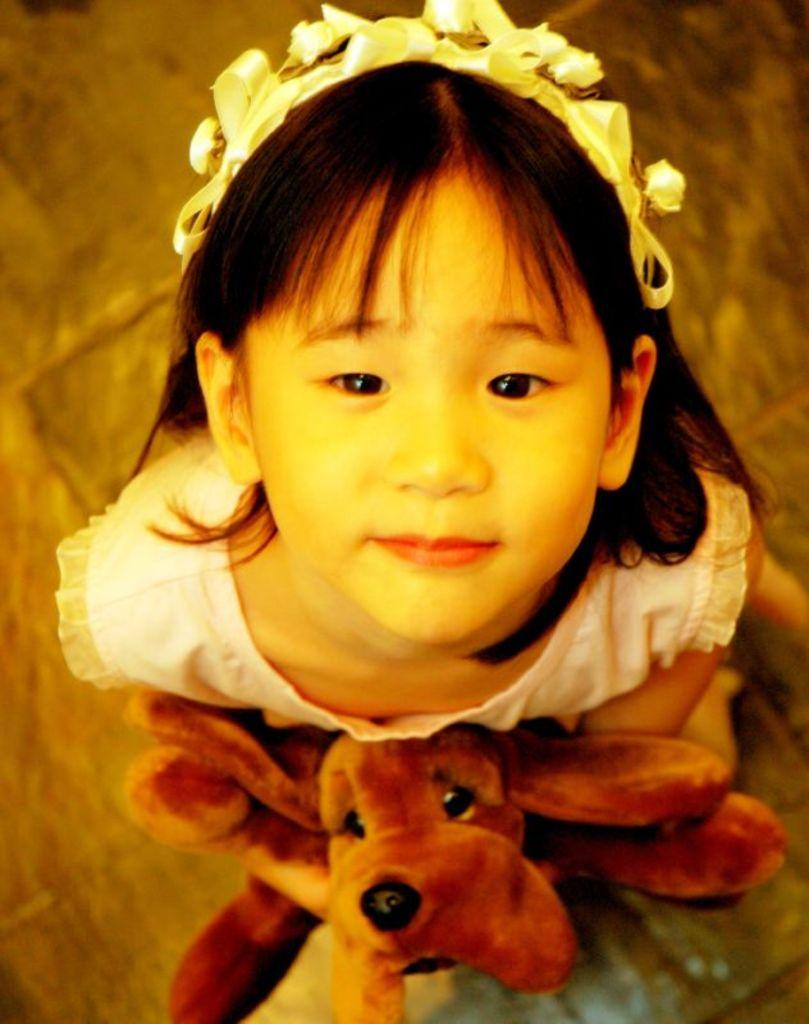What is the main subject of the image? The main subject of the image is a kid. What is the kid holding in her hands? The kid is holding a dog toy in her hands. What direction is the kid looking in? The kid is looking upwards. What type of duck can be seen swimming in the image? There is no duck present in the image; it features a kid holding a dog toy and looking upwards. What is the stem of the body in the image? There is no stem or body present in the image, as it only features a kid holding a dog toy and looking upwards. 